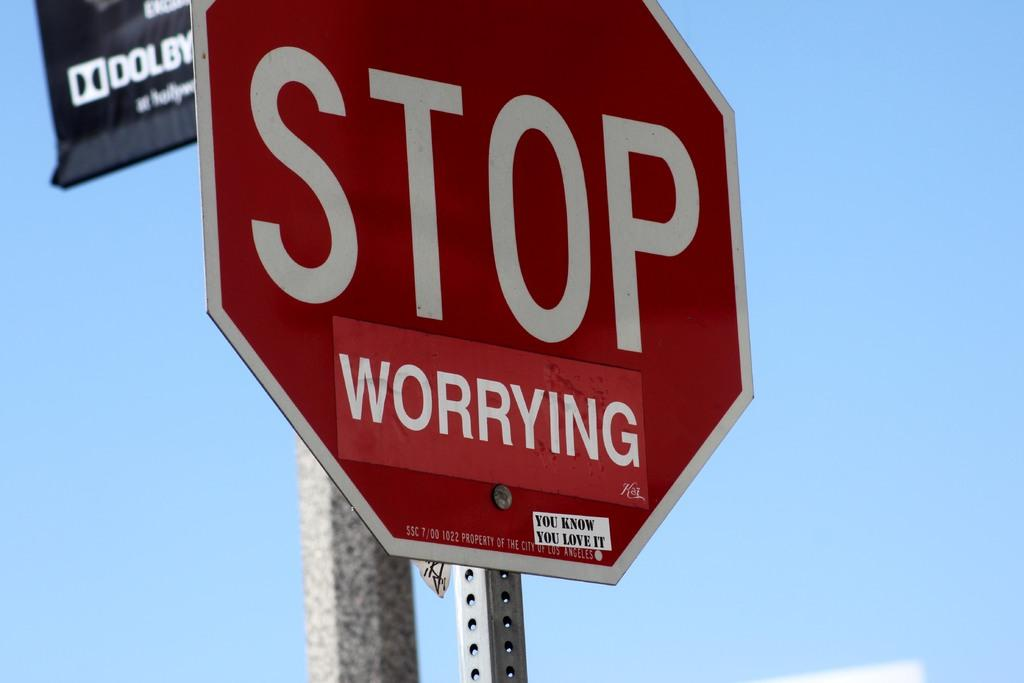<image>
Write a terse but informative summary of the picture. A stop sign that says stop worrying on it. 